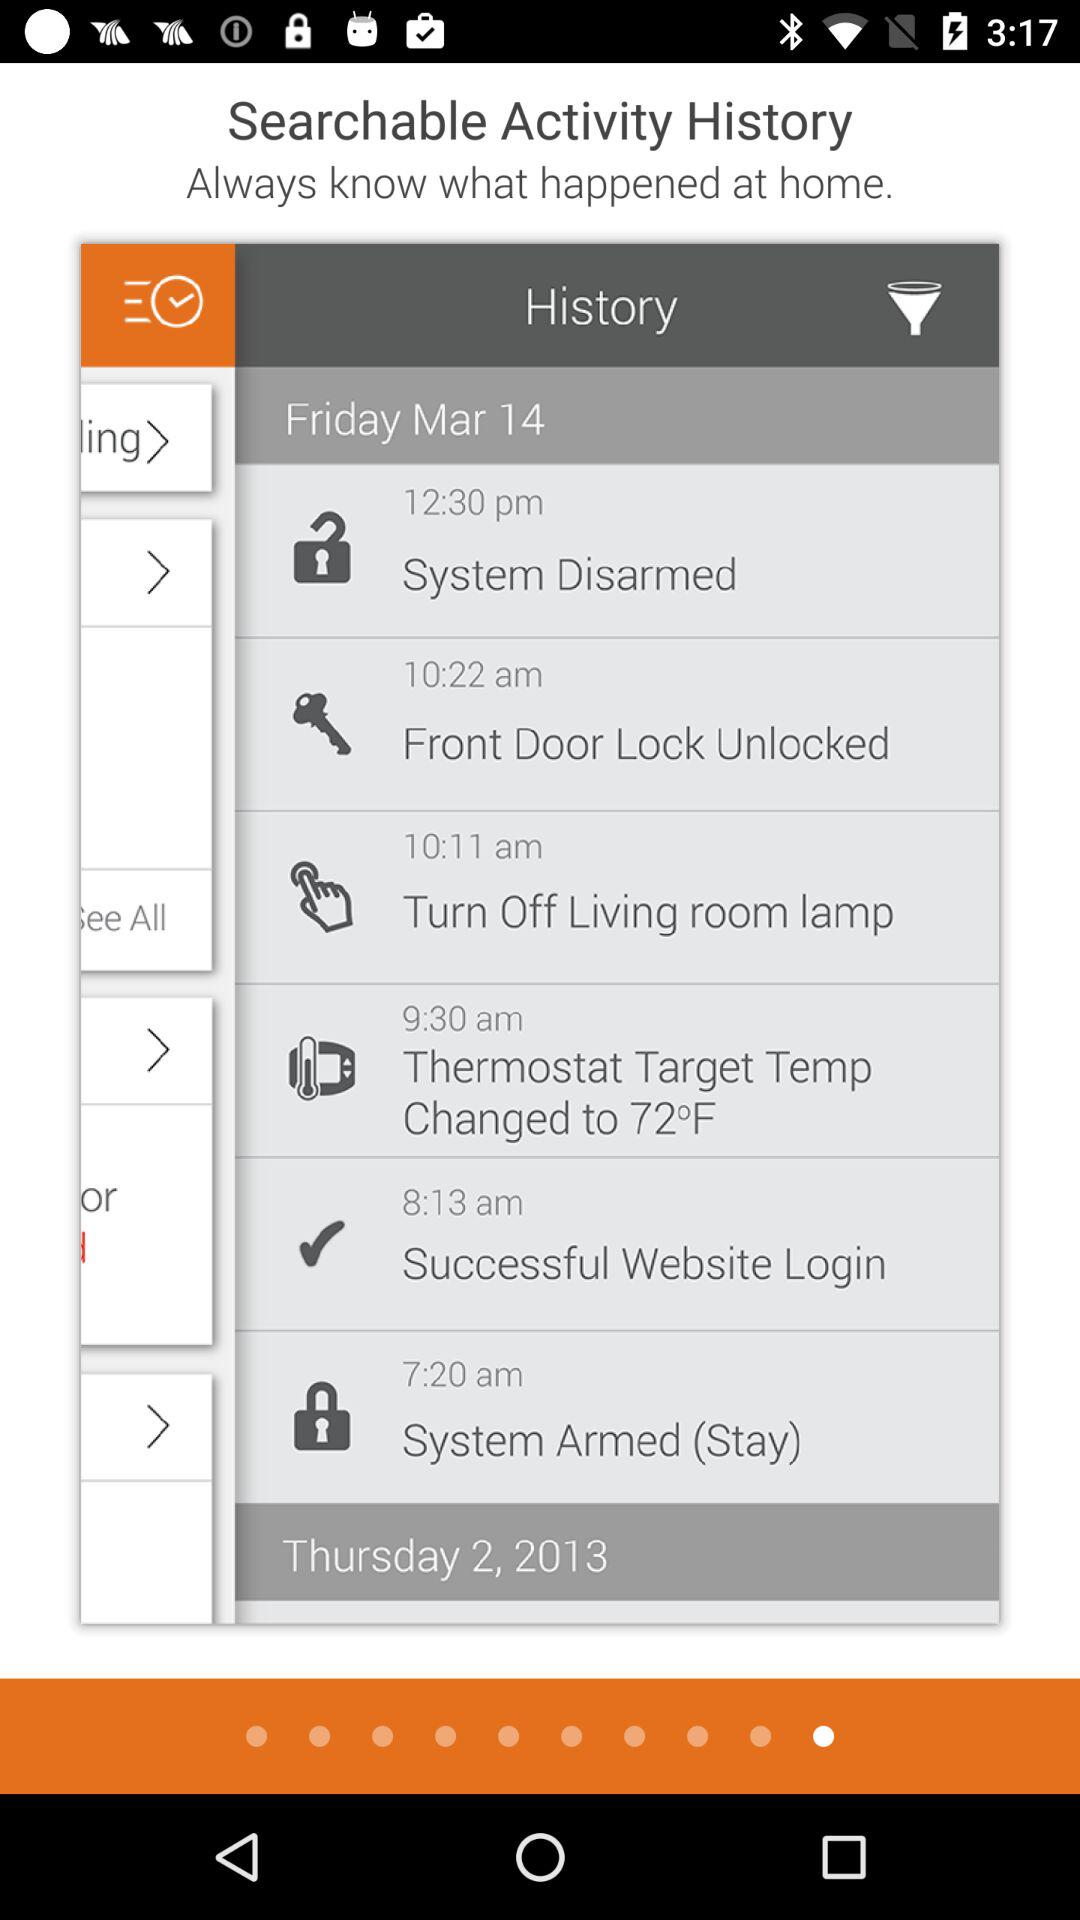What dates are given in history? The dates are Friday, March 14 and Thursday 2, 2013. 